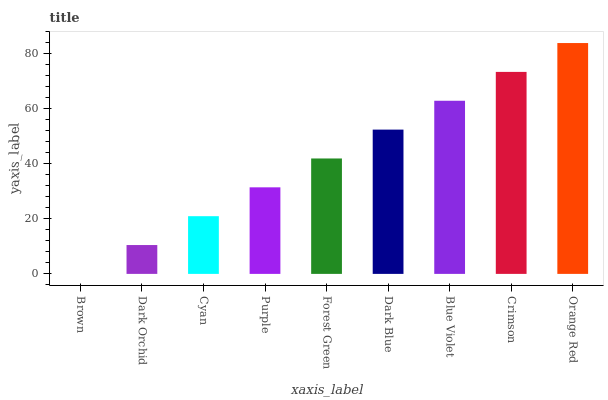Is Brown the minimum?
Answer yes or no. Yes. Is Orange Red the maximum?
Answer yes or no. Yes. Is Dark Orchid the minimum?
Answer yes or no. No. Is Dark Orchid the maximum?
Answer yes or no. No. Is Dark Orchid greater than Brown?
Answer yes or no. Yes. Is Brown less than Dark Orchid?
Answer yes or no. Yes. Is Brown greater than Dark Orchid?
Answer yes or no. No. Is Dark Orchid less than Brown?
Answer yes or no. No. Is Forest Green the high median?
Answer yes or no. Yes. Is Forest Green the low median?
Answer yes or no. Yes. Is Dark Blue the high median?
Answer yes or no. No. Is Blue Violet the low median?
Answer yes or no. No. 